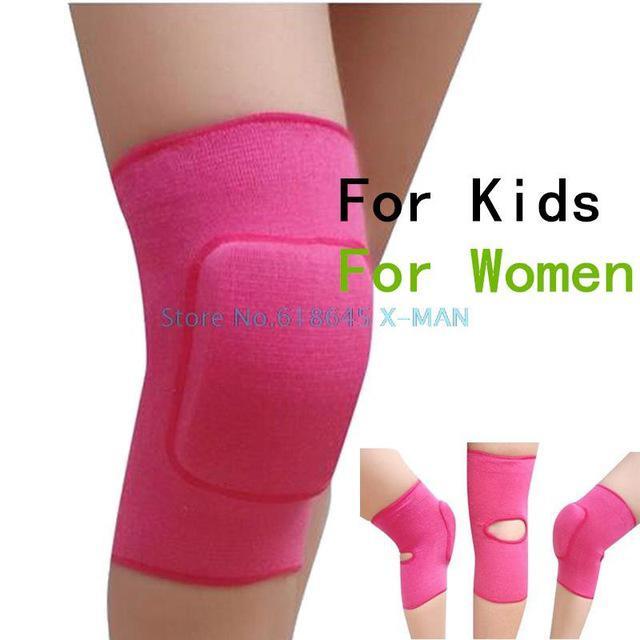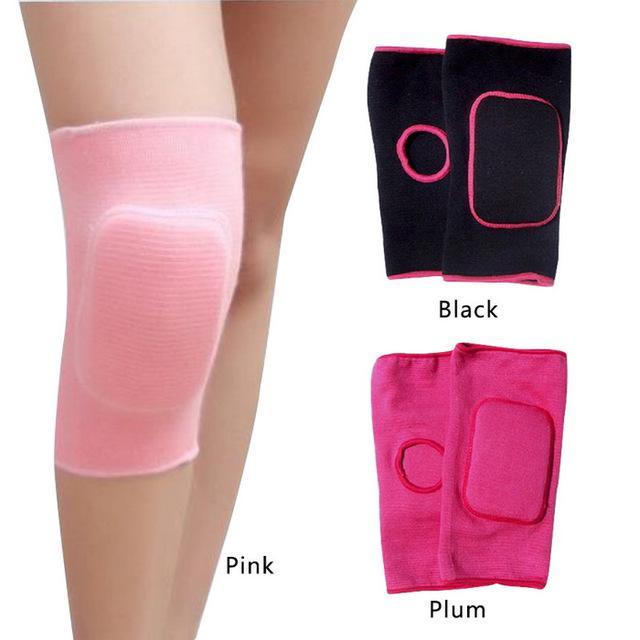The first image is the image on the left, the second image is the image on the right. Analyze the images presented: Is the assertion "There is at least one unworn knee pad to the right of a model's legs." valid? Answer yes or no. Yes. The first image is the image on the left, the second image is the image on the right. Analyze the images presented: Is the assertion "Each image contains a pair of legs with the leg on the left bent and overlapping the right leg, and each image includes at least one hot pink knee pad." valid? Answer yes or no. Yes. 